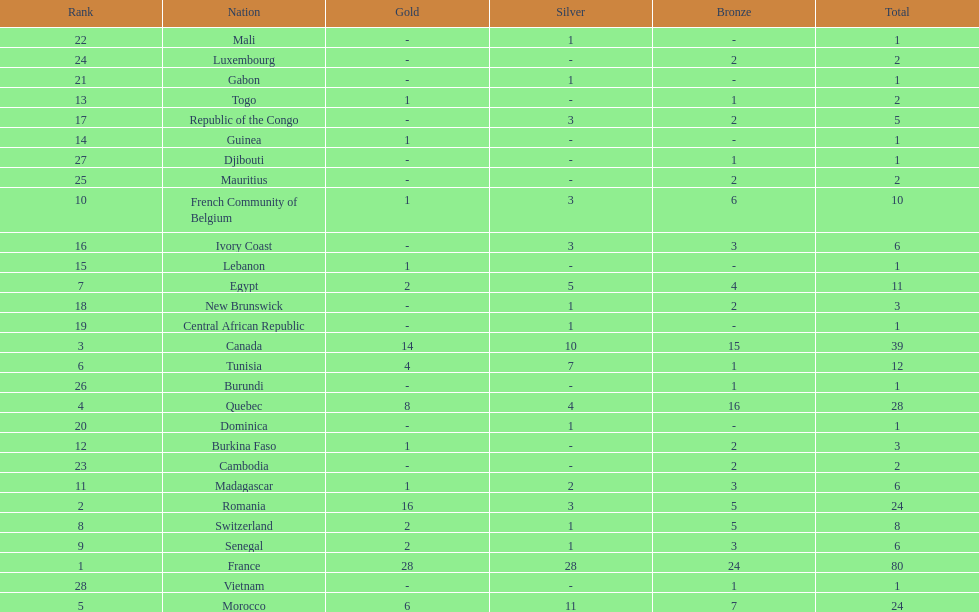How many counties have at least one silver medal? 18. 